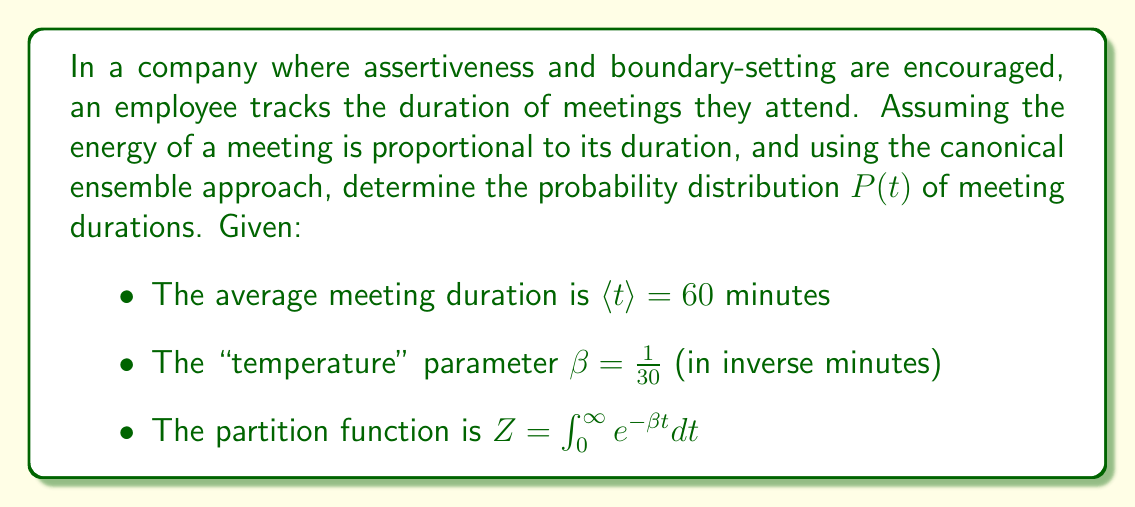Could you help me with this problem? 1) In the canonical ensemble, the probability distribution is given by:
   $$P(t) = \frac{1}{Z} e^{-\beta E(t)}$$

2) Since the energy is proportional to duration, we can write $E(t) = t$:
   $$P(t) = \frac{1}{Z} e^{-\beta t}$$

3) Calculate the partition function $Z$:
   $$Z = \int_0^{\infty} e^{-\beta t} dt = \left[-\frac{1}{\beta} e^{-\beta t}\right]_0^{\infty} = \frac{1}{\beta}$$

4) Substitute $Z = \frac{1}{\beta}$ into the probability distribution:
   $$P(t) = \beta e^{-\beta t}$$

5) This is an exponential distribution with parameter $\beta$.

6) Verify using the average duration:
   $$\langle t \rangle = \int_0^{\infty} t P(t) dt = \int_0^{\infty} t \beta e^{-\beta t} dt = \frac{1}{\beta} = 60$$

   This confirms $\beta = \frac{1}{60}$, which matches the given value.

7) Therefore, the final probability distribution is:
   $$P(t) = \frac{1}{60} e^{-t/60}$$
Answer: $P(t) = \frac{1}{60} e^{-t/60}$ 